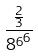<formula> <loc_0><loc_0><loc_500><loc_500>\frac { \frac { 2 } { 3 } } { { 8 ^ { 6 } } ^ { 6 } }</formula> 